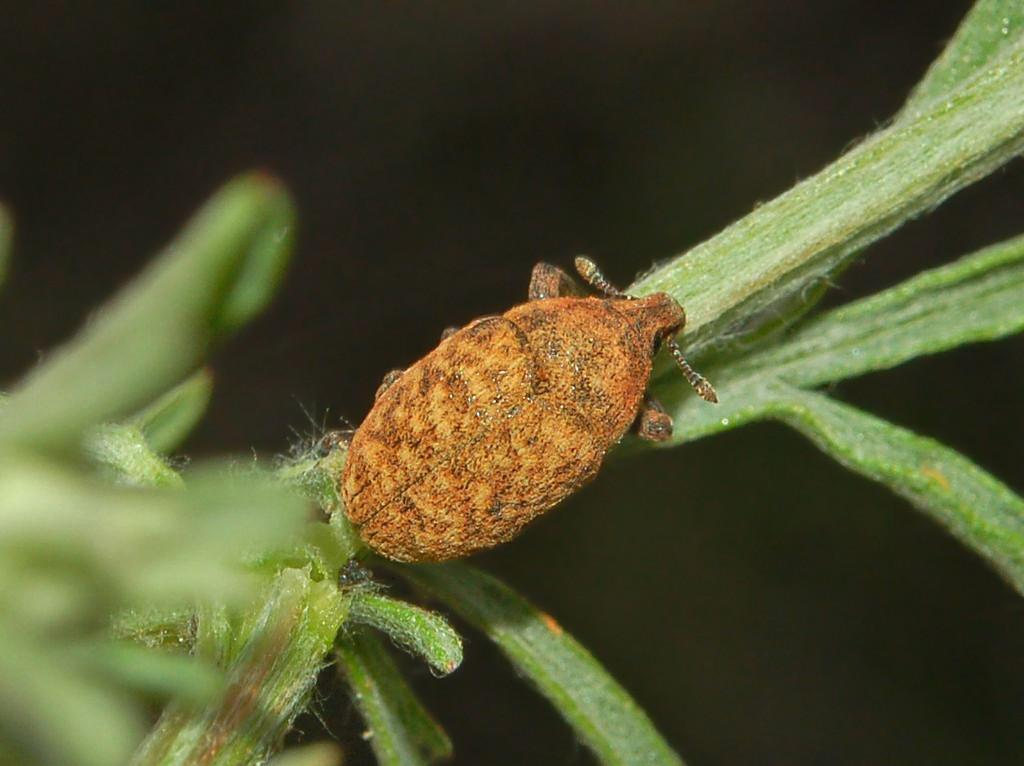What is the main subject in the center of the image? There is a plant in the center of the image. Is there anything on the plant? Yes, there is an insect on the plant. What can be said about the color of the insect? The insect is brown in color. Can you tell me how many books are floating in the river in the image? There is no river or books present in the image; it features a plant with an insect on it. What type of creature is shown interacting with the plant in the image? There is no creature shown interacting with the plant in the image; only the insect is present. 